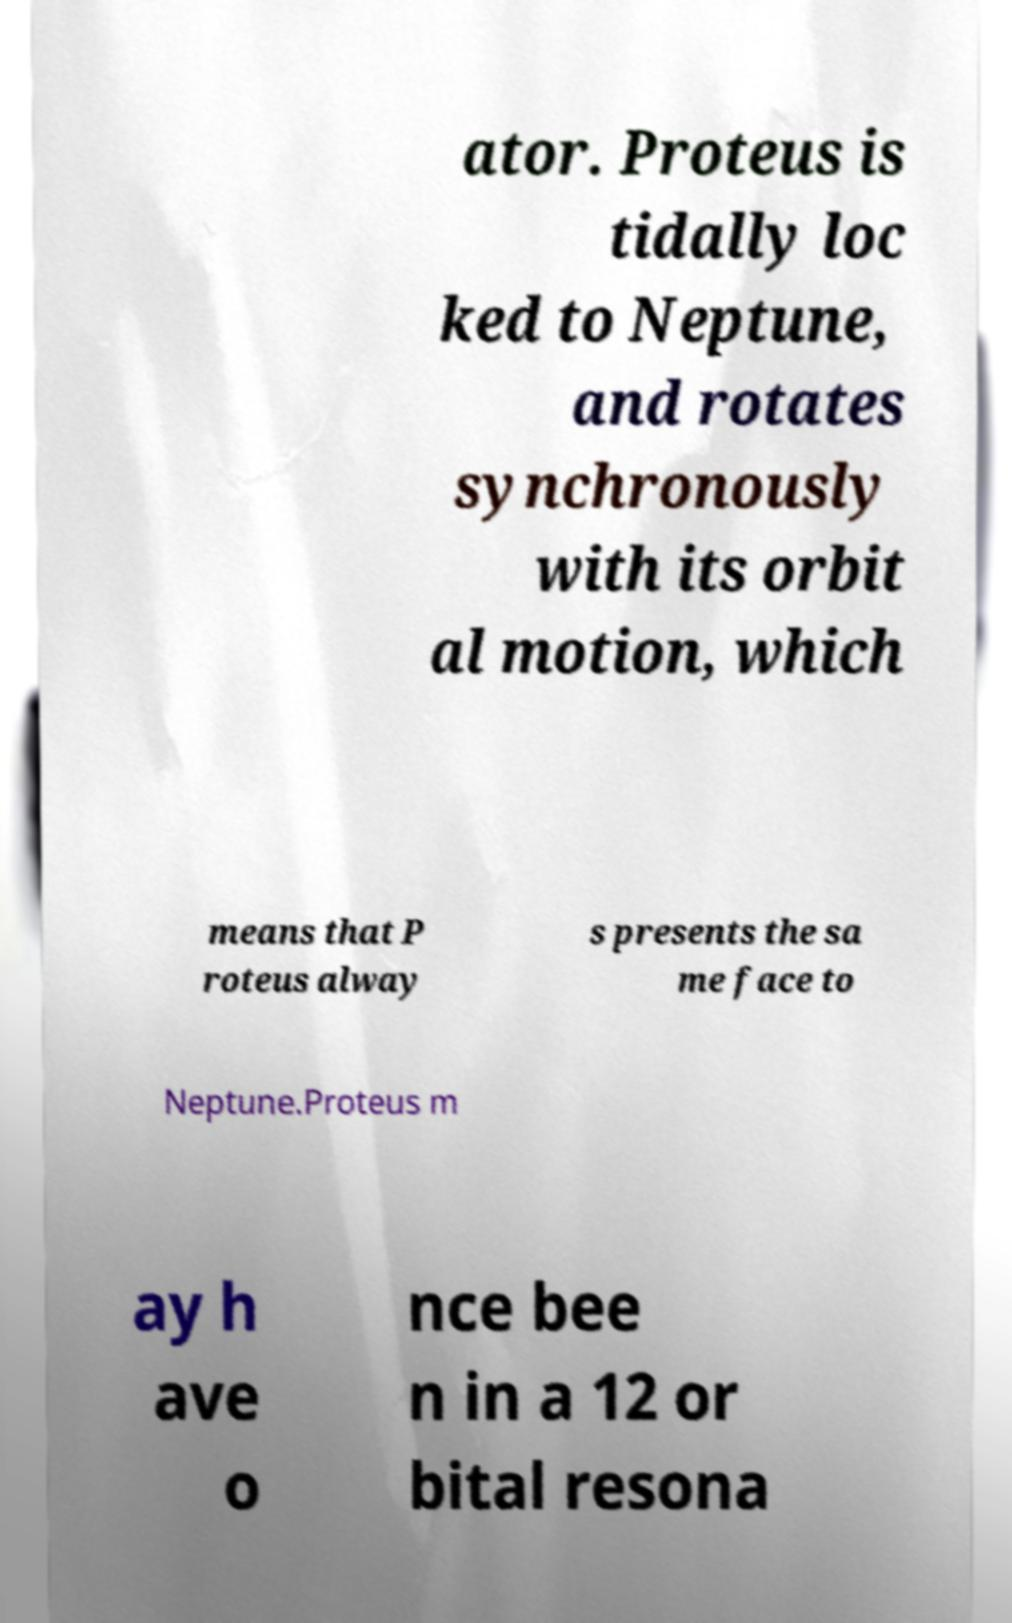I need the written content from this picture converted into text. Can you do that? ator. Proteus is tidally loc ked to Neptune, and rotates synchronously with its orbit al motion, which means that P roteus alway s presents the sa me face to Neptune.Proteus m ay h ave o nce bee n in a 12 or bital resona 